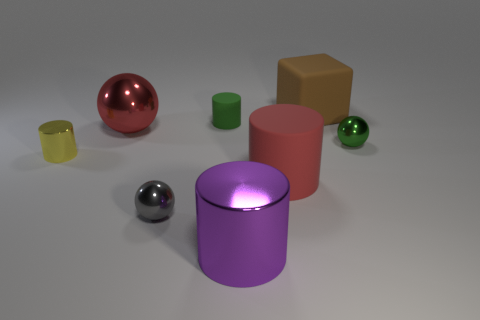Is there anything else that has the same shape as the brown thing?
Ensure brevity in your answer.  No. There is a ball that is right of the big shiny thing that is in front of the small metal ball on the left side of the green matte cylinder; what size is it?
Your response must be concise. Small. What color is the small cylinder that is in front of the green metallic thing behind the big metal cylinder?
Ensure brevity in your answer.  Yellow. How many other things are there of the same material as the yellow cylinder?
Ensure brevity in your answer.  4. How many other things are the same color as the big metallic cylinder?
Ensure brevity in your answer.  0. What material is the red object behind the green ball that is behind the small yellow cylinder?
Ensure brevity in your answer.  Metal. Are any gray cylinders visible?
Offer a very short reply. No. There is a green object left of the tiny sphere to the right of the big purple cylinder; what is its size?
Your answer should be very brief. Small. Are there more purple cylinders that are in front of the large brown cube than purple metallic cylinders that are on the left side of the small gray thing?
Keep it short and to the point. Yes. What number of cubes are big red shiny things or large brown objects?
Your answer should be very brief. 1. 